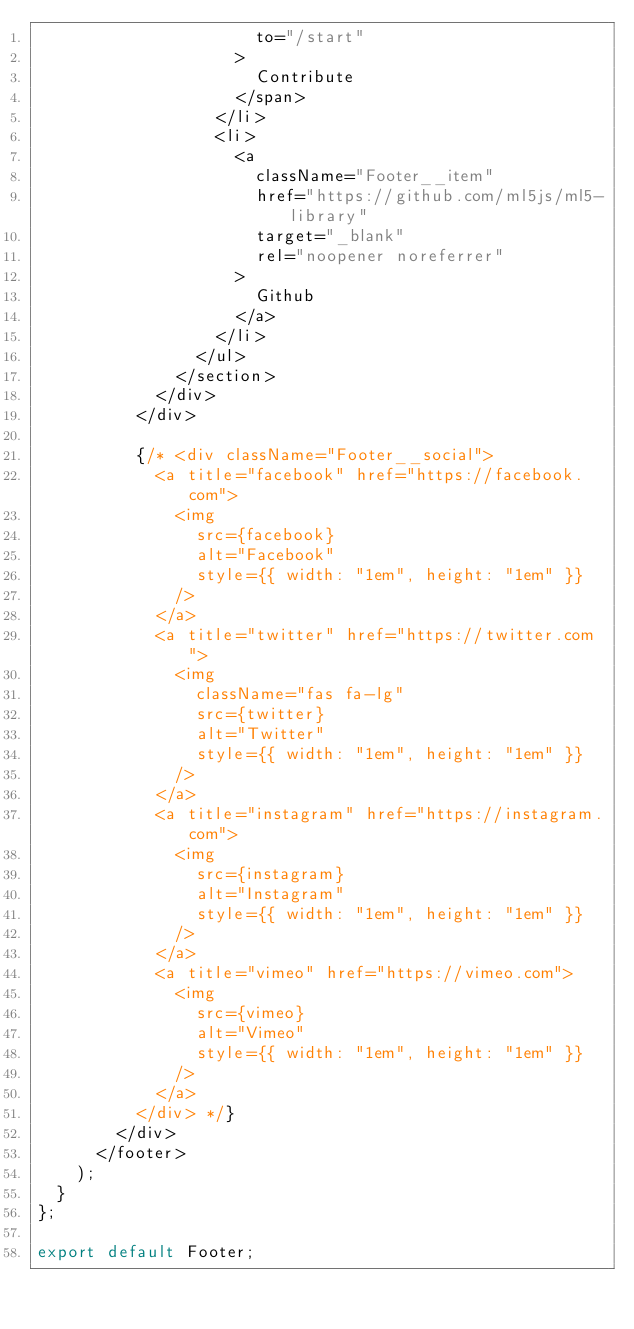Convert code to text. <code><loc_0><loc_0><loc_500><loc_500><_JavaScript_>                      to="/start"
                    >
                      Contribute
                    </span>
                  </li>
                  <li>
                    <a
                      className="Footer__item"
                      href="https://github.com/ml5js/ml5-library"
                      target="_blank"
                      rel="noopener noreferrer"
                    >
                      Github
                    </a>
                  </li>
                </ul>
              </section>
            </div>
          </div>

          {/* <div className="Footer__social">
            <a title="facebook" href="https://facebook.com">
              <img
                src={facebook}
                alt="Facebook"
                style={{ width: "1em", height: "1em" }}
              />
            </a>
            <a title="twitter" href="https://twitter.com">
              <img
                className="fas fa-lg"
                src={twitter}
                alt="Twitter"
                style={{ width: "1em", height: "1em" }}
              />
            </a>
            <a title="instagram" href="https://instagram.com">
              <img
                src={instagram}
                alt="Instagram"
                style={{ width: "1em", height: "1em" }}
              />
            </a>
            <a title="vimeo" href="https://vimeo.com">
              <img
                src={vimeo}
                alt="Vimeo"
                style={{ width: "1em", height: "1em" }}
              />
            </a>
          </div> */}
        </div>
      </footer>
    );
  }
};

export default Footer;
</code> 